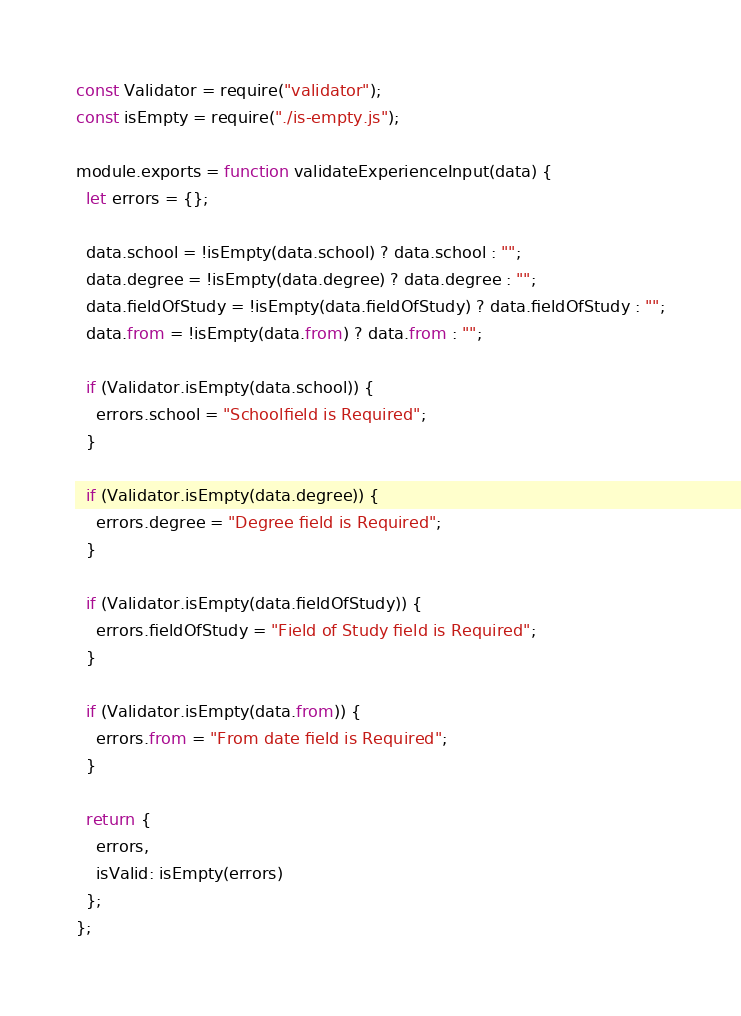Convert code to text. <code><loc_0><loc_0><loc_500><loc_500><_JavaScript_>const Validator = require("validator");
const isEmpty = require("./is-empty.js");

module.exports = function validateExperienceInput(data) {
  let errors = {};

  data.school = !isEmpty(data.school) ? data.school : "";
  data.degree = !isEmpty(data.degree) ? data.degree : "";
  data.fieldOfStudy = !isEmpty(data.fieldOfStudy) ? data.fieldOfStudy : "";
  data.from = !isEmpty(data.from) ? data.from : "";

  if (Validator.isEmpty(data.school)) {
    errors.school = "Schoolfield is Required";
  }

  if (Validator.isEmpty(data.degree)) {
    errors.degree = "Degree field is Required";
  }

  if (Validator.isEmpty(data.fieldOfStudy)) {
    errors.fieldOfStudy = "Field of Study field is Required";
  }

  if (Validator.isEmpty(data.from)) {
    errors.from = "From date field is Required";
  }

  return {
    errors,
    isValid: isEmpty(errors)
  };
};
</code> 